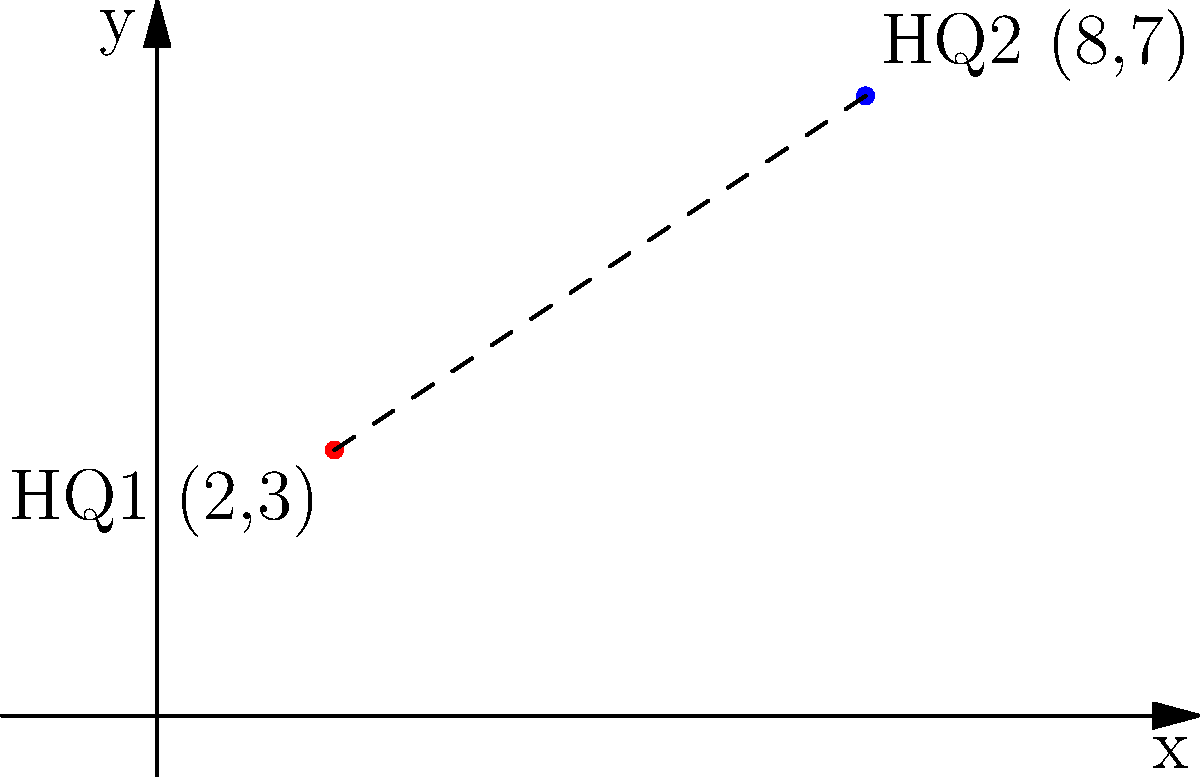Two major companies in Mexico City are planning a merger. Their headquarters are located on a coordinate plane representing the city map. Company A's headquarters is at point (2,3), while Company B's headquarters is at point (8,7). As part of your merger analysis, calculate the straight-line distance between these two headquarters. To find the distance between two points on a coordinate plane, we can use the distance formula, which is derived from the Pythagorean theorem:

$$ d = \sqrt{(x_2 - x_1)^2 + (y_2 - y_1)^2} $$

Where $(x_1, y_1)$ is the coordinate of the first point and $(x_2, y_2)$ is the coordinate of the second point.

Let's plug in our values:
- Company A (HQ1): $(x_1, y_1) = (2, 3)$
- Company B (HQ2): $(x_2, y_2) = (8, 7)$

Now, let's calculate:

$$ d = \sqrt{(8 - 2)^2 + (7 - 3)^2} $$
$$ d = \sqrt{6^2 + 4^2} $$
$$ d = \sqrt{36 + 16} $$
$$ d = \sqrt{52} $$
$$ d = 2\sqrt{13} \approx 7.21 $$

Therefore, the distance between the two headquarters is $2\sqrt{13}$ units, or approximately 7.21 units on the city map scale.
Answer: $2\sqrt{13}$ units 